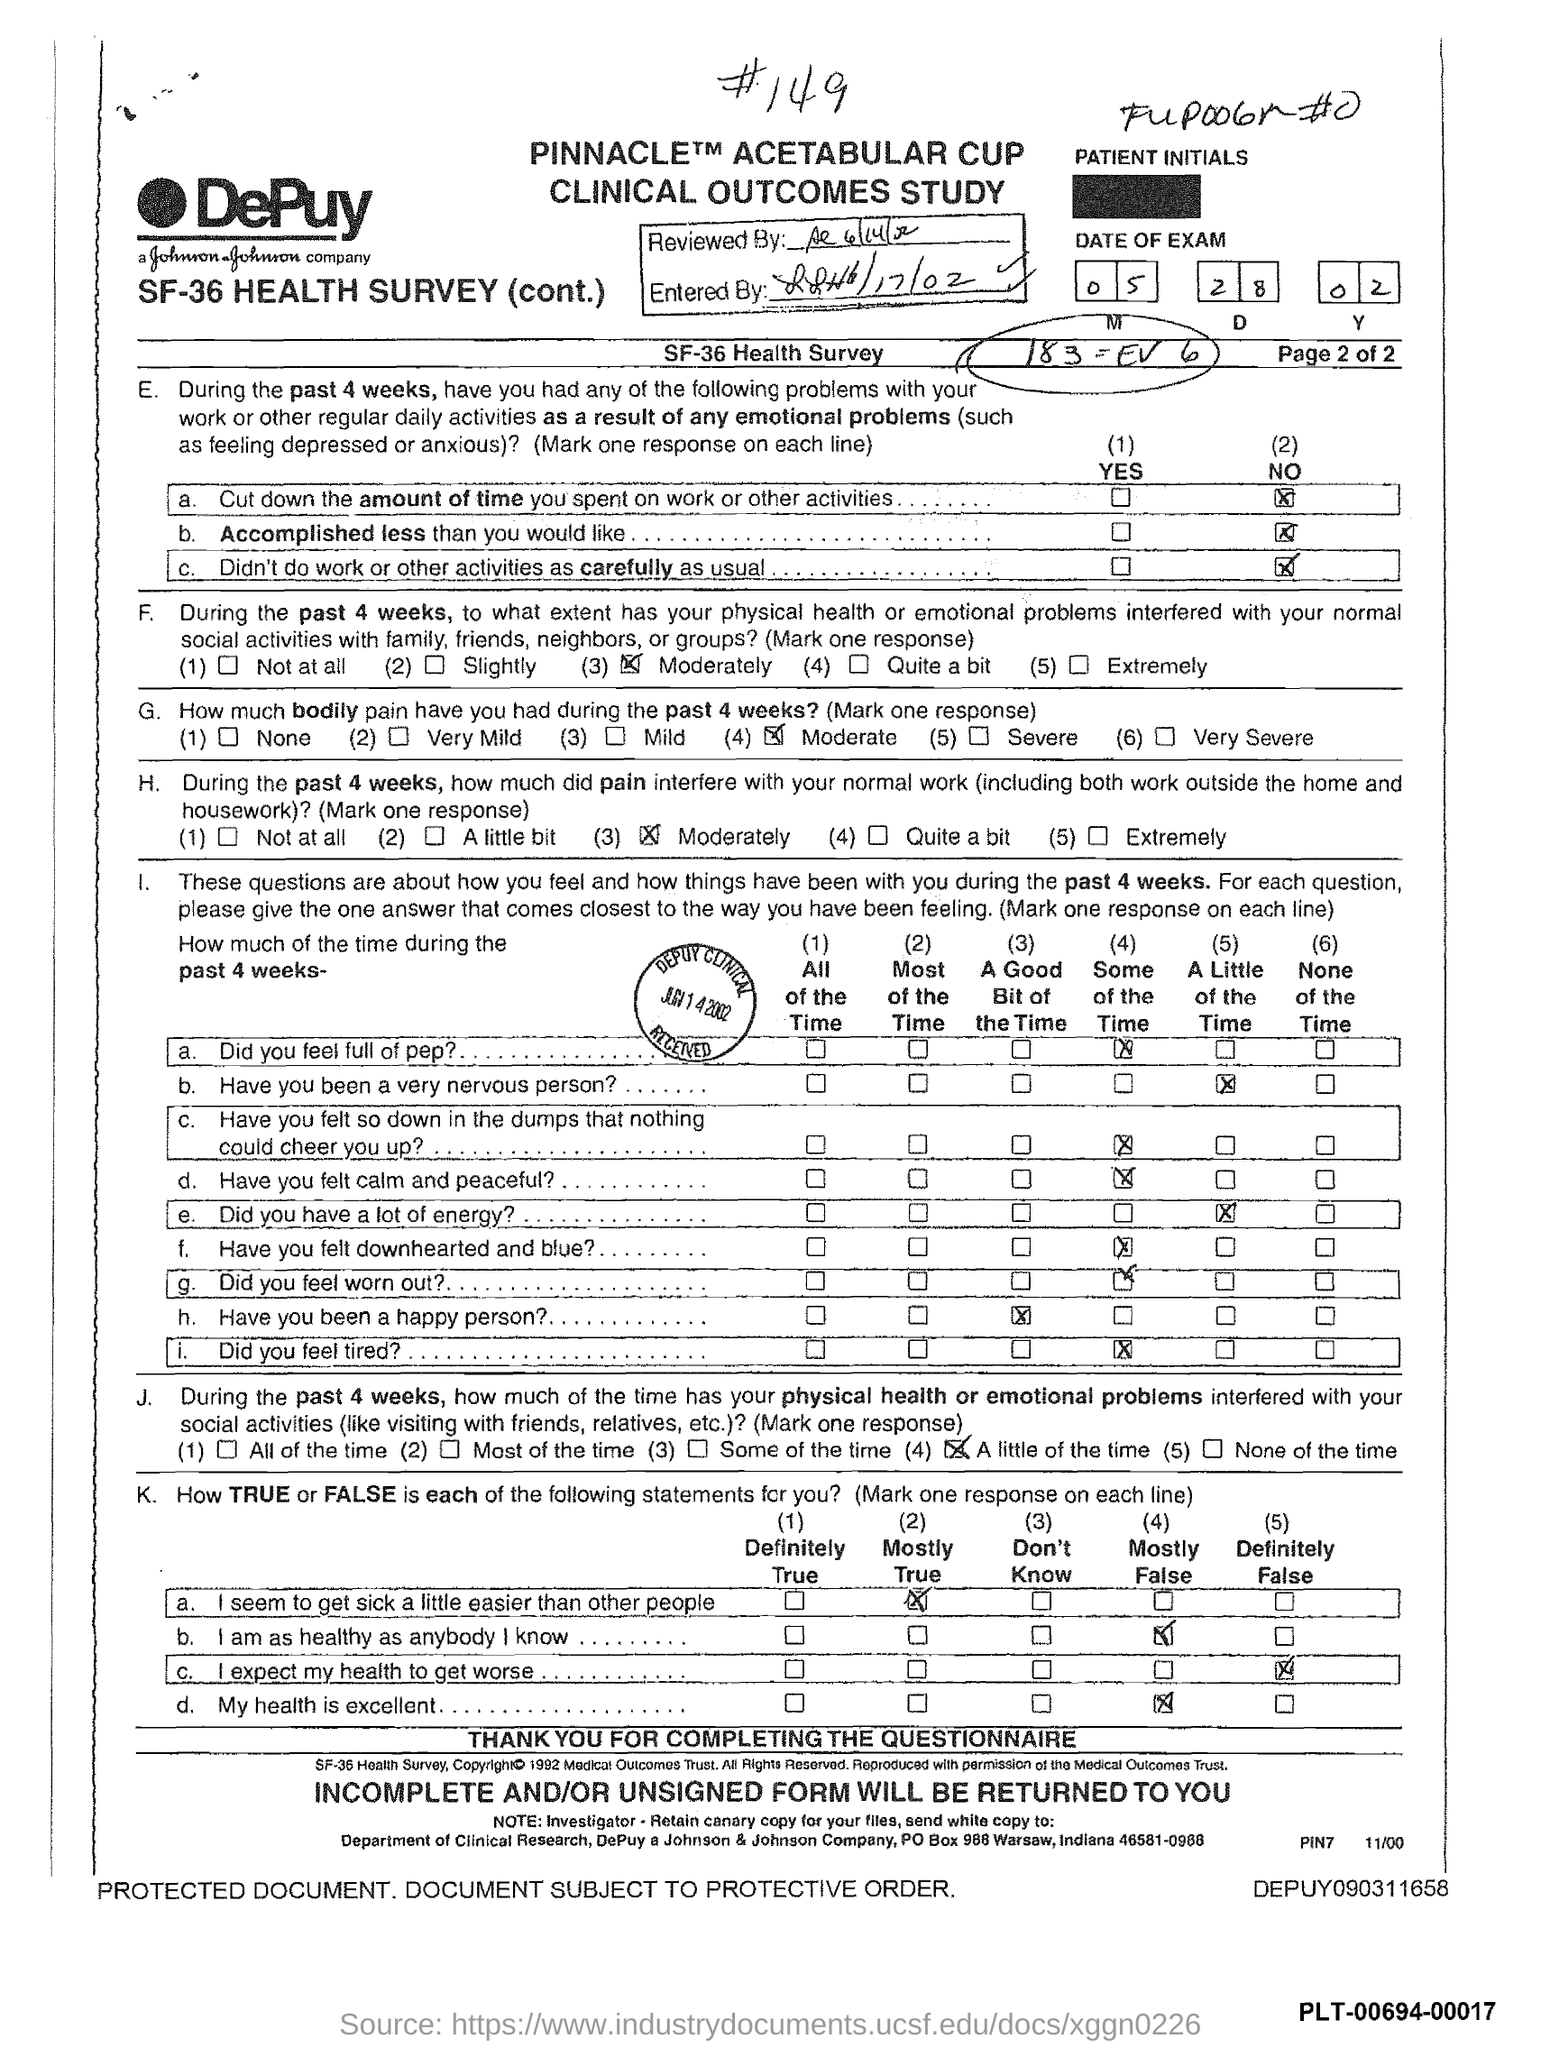Specify some key components in this picture. The month of the exam mentioned in the document is May. 